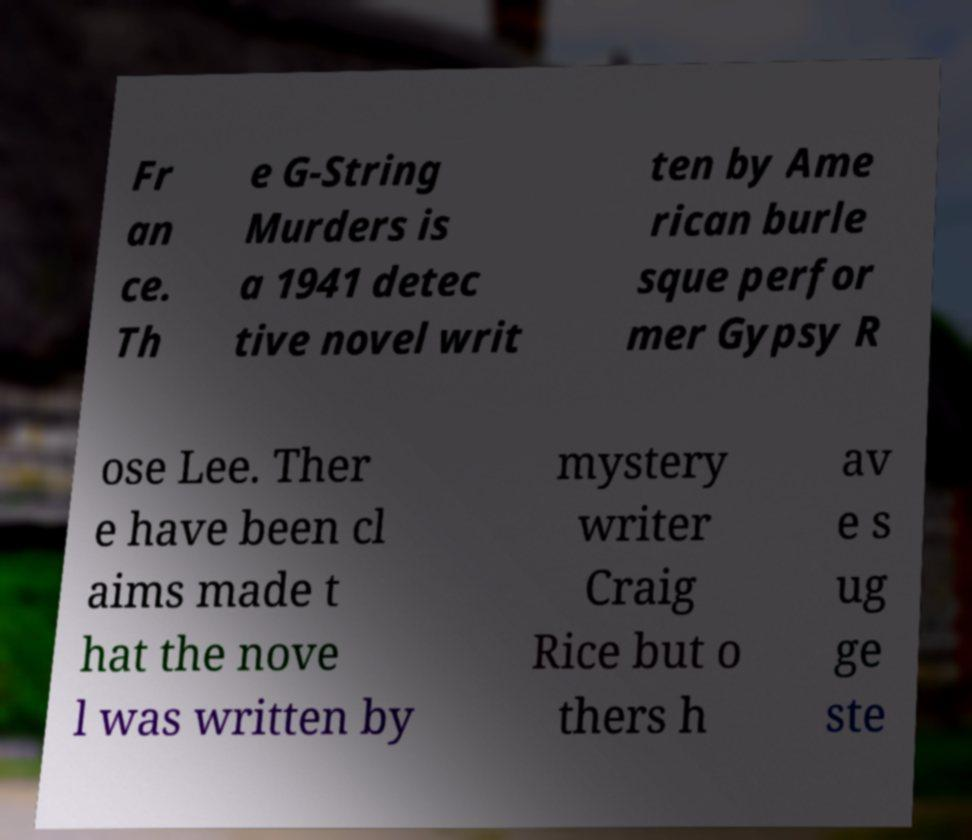For documentation purposes, I need the text within this image transcribed. Could you provide that? Fr an ce. Th e G-String Murders is a 1941 detec tive novel writ ten by Ame rican burle sque perfor mer Gypsy R ose Lee. Ther e have been cl aims made t hat the nove l was written by mystery writer Craig Rice but o thers h av e s ug ge ste 